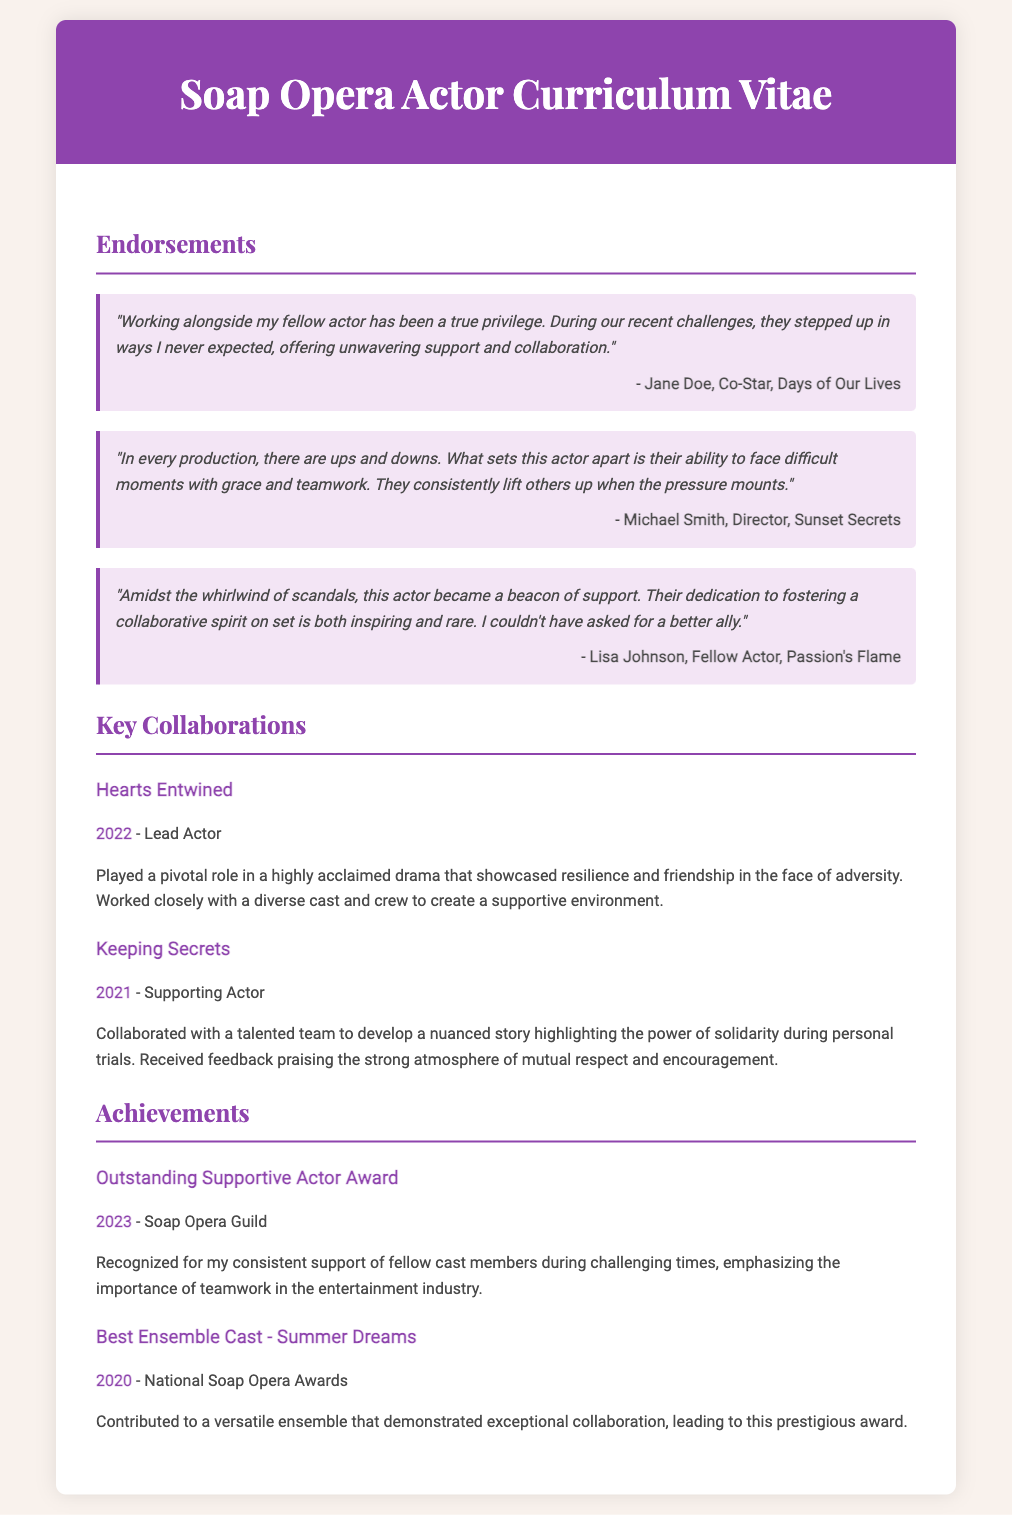What did Jane Doe describe their fellow actor as? Jane Doe praised their fellow actor as having "unwavering support and collaboration" during challenges.
Answer: unwavering support and collaboration What year was the Outstanding Supportive Actor Award received? The document states the year the award was received, which is 2023.
Answer: 2023 Who directed Sunset Secrets? Michael Smith is mentioned as the director of Sunset Secrets in the endorsements section.
Answer: Michael Smith In which collaboration did the actor play the role of Lead Actor? The document specifies the production where the actor held the Lead Actor role as "Hearts Entwined."
Answer: Hearts Entwined What theme was highlighted in the "Keeping Secrets" production? The document notes that the production emphasized "the power of solidarity during personal trials."
Answer: the power of solidarity during personal trials How many endorsements are listed in the document? The total number of endorsements provided in the document is three.
Answer: three What is a key quality that distinguishes this actor according to Michael Smith? Michael Smith emphasizes the actor's ability to "face difficult moments with grace and teamwork."
Answer: grace and teamwork What prestigious award did the ensemble cast win in 2020? The document states that the award won by the Best Ensemble Cast was related to "Summer Dreams."
Answer: Summer Dreams 